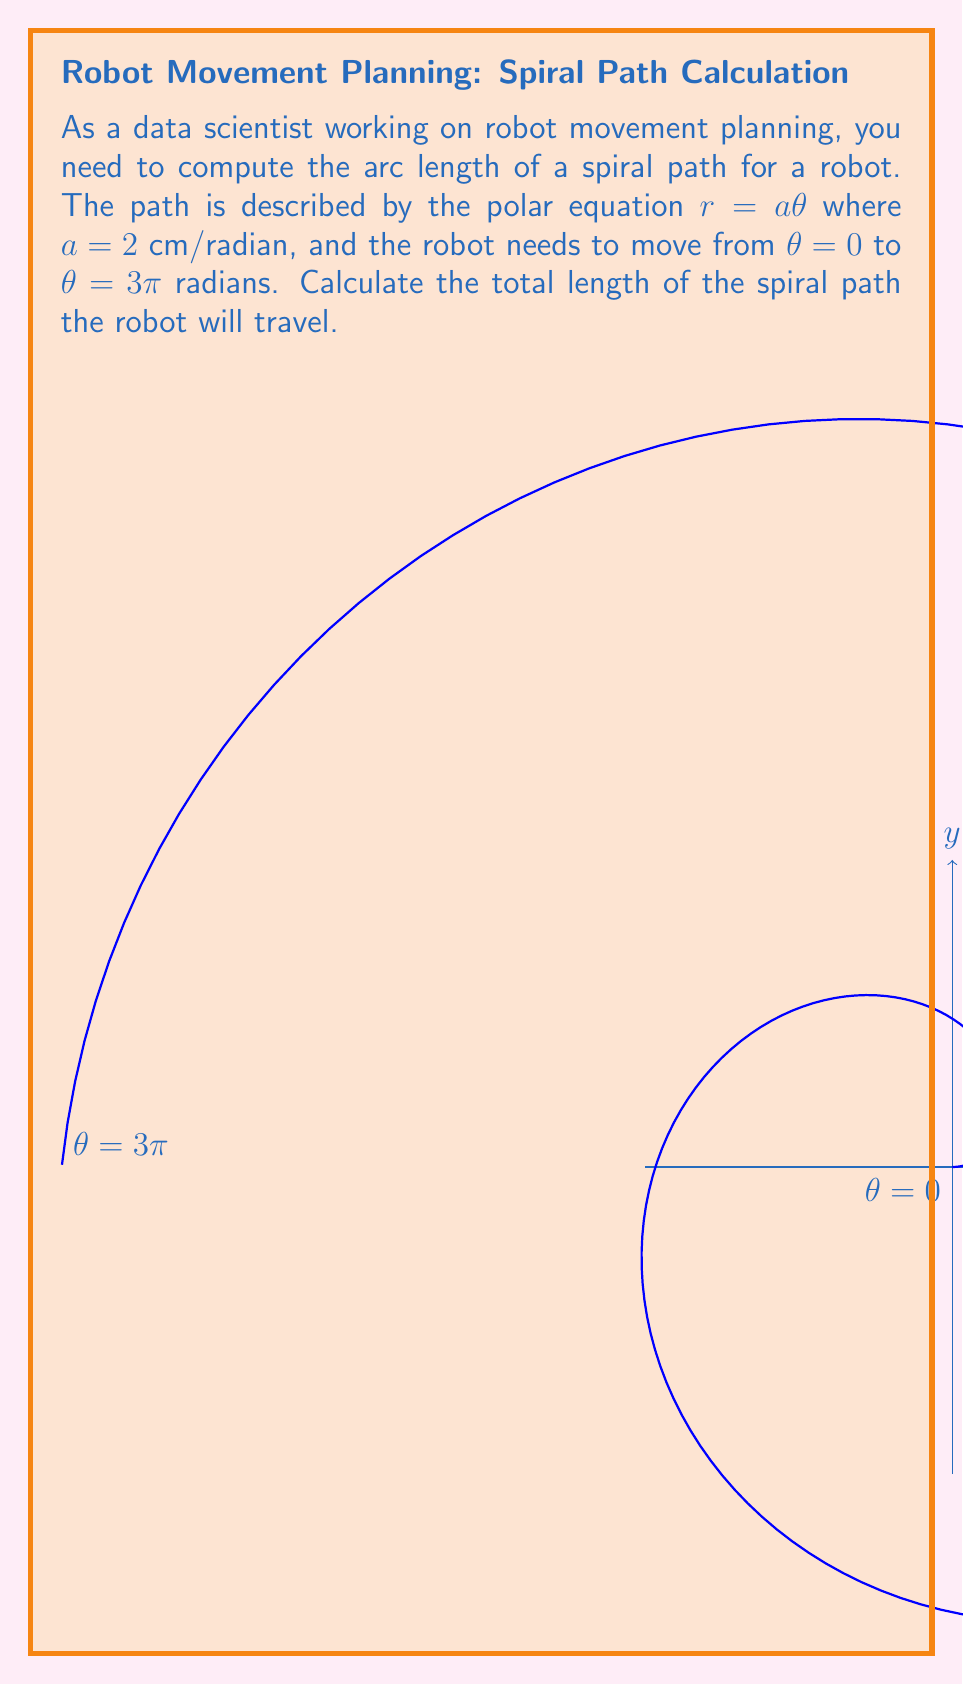Could you help me with this problem? To solve this problem, we'll follow these steps:

1) The formula for the arc length of a curve in polar coordinates is:

   $$L = \int_{\theta_1}^{\theta_2} \sqrt{r^2 + \left(\frac{dr}{d\theta}\right)^2} d\theta$$

2) We're given $r = a\theta$ where $a = 2$ cm/radian. Let's find $\frac{dr}{d\theta}$:

   $$\frac{dr}{d\theta} = a = 2$$

3) Now, let's substitute these into our arc length formula:

   $$L = \int_0^{3\pi} \sqrt{(a\theta)^2 + a^2} d\theta$$

4) Substituting $a = 2$:

   $$L = \int_0^{3\pi} \sqrt{(2\theta)^2 + 2^2} d\theta = 2\int_0^{3\pi} \sqrt{\theta^2 + 1} d\theta$$

5) This integral doesn't have an elementary antiderivative. We can solve it using the hyperbolic functions:

   $$L = 2[\theta \sinh^{-1}(\theta) + \sqrt{\theta^2 + 1}]_0^{3\pi}$$

6) Evaluating at the limits:

   $$L = 2[(3\pi \sinh^{-1}(3\pi) + \sqrt{(3\pi)^2 + 1}) - (0 \sinh^{-1}(0) + \sqrt{0^2 + 1})]$$

7) Simplifying:

   $$L = 2[3\pi \sinh^{-1}(3\pi) + \sqrt{9\pi^2 + 1} - 1]$$

8) Using a calculator to evaluate this expression (rounded to two decimal places):

   $$L \approx 59.92 \text{ cm}$$
Answer: $59.92$ cm 